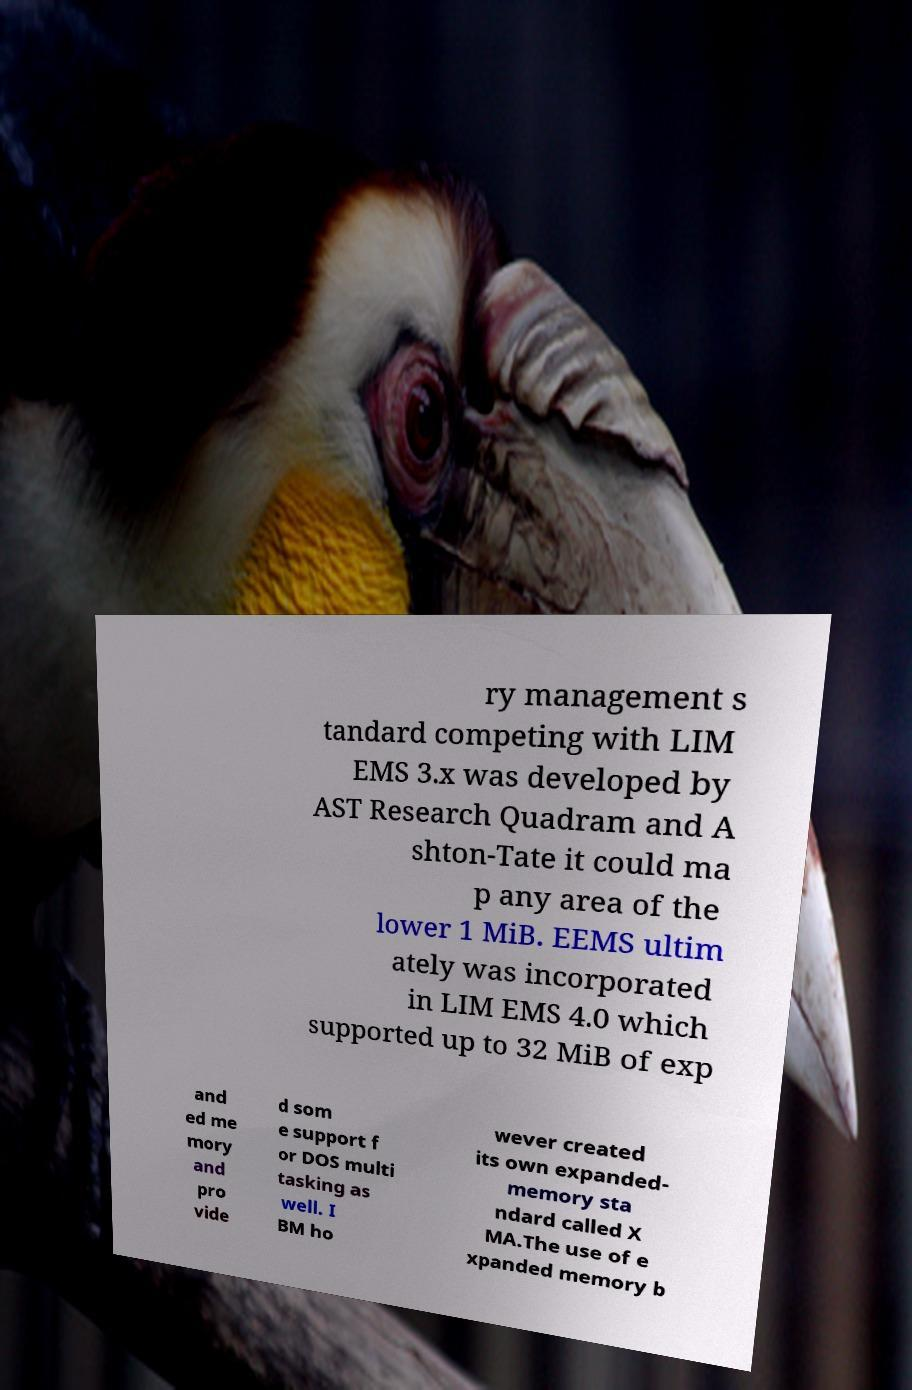Please identify and transcribe the text found in this image. ry management s tandard competing with LIM EMS 3.x was developed by AST Research Quadram and A shton-Tate it could ma p any area of the lower 1 MiB. EEMS ultim ately was incorporated in LIM EMS 4.0 which supported up to 32 MiB of exp and ed me mory and pro vide d som e support f or DOS multi tasking as well. I BM ho wever created its own expanded- memory sta ndard called X MA.The use of e xpanded memory b 